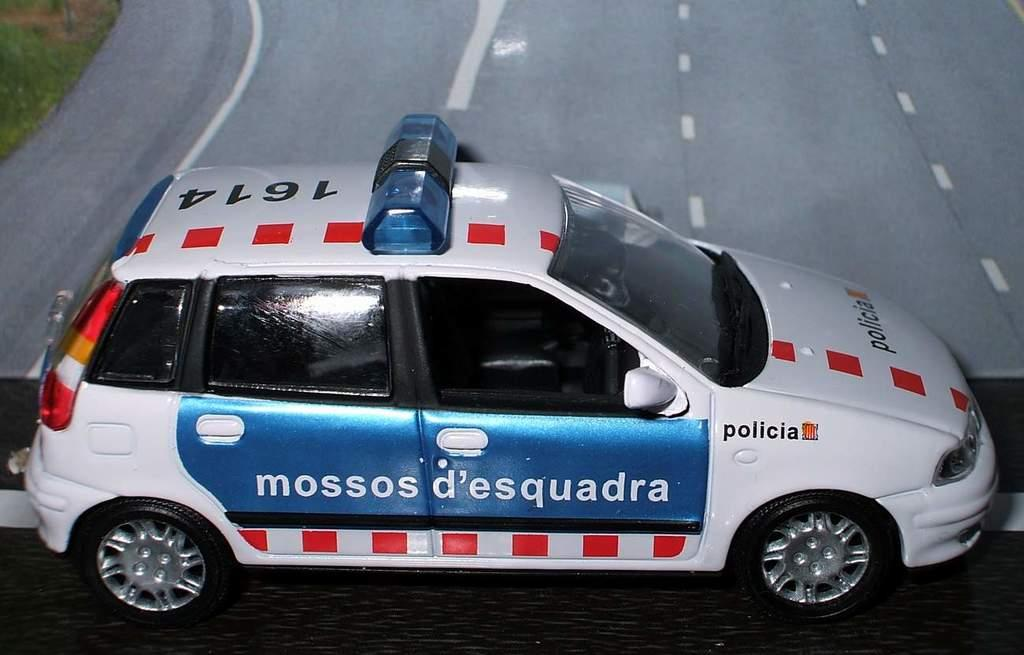What type of toy is in the image? There is a toy police car in the image. What can be seen in the background of the image? There is a picture of a road in the background of the image. What type of fruit is hanging from the toy police car in the image? There is no fruit present in the image, and it is not hanging from the toy police car. 